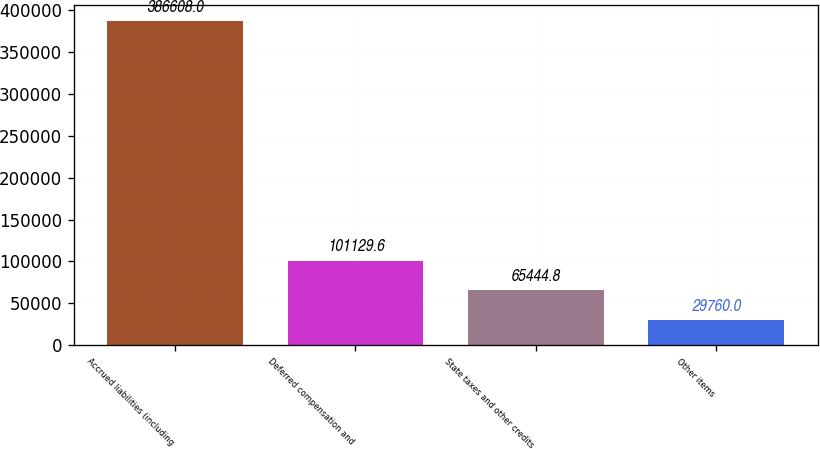Convert chart to OTSL. <chart><loc_0><loc_0><loc_500><loc_500><bar_chart><fcel>Accrued liabilities (including<fcel>Deferred compensation and<fcel>State taxes and other credits<fcel>Other items<nl><fcel>386608<fcel>101130<fcel>65444.8<fcel>29760<nl></chart> 